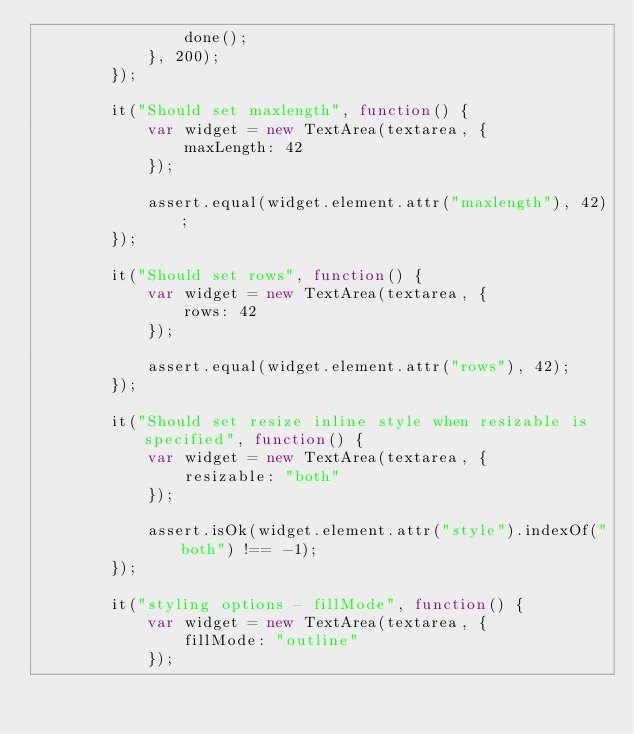Convert code to text. <code><loc_0><loc_0><loc_500><loc_500><_JavaScript_>                done();
            }, 200);
        });

        it("Should set maxlength", function() {
            var widget = new TextArea(textarea, {
                maxLength: 42
            });

            assert.equal(widget.element.attr("maxlength"), 42);
        });

        it("Should set rows", function() {
            var widget = new TextArea(textarea, {
                rows: 42
            });

            assert.equal(widget.element.attr("rows"), 42);
        });

        it("Should set resize inline style when resizable is specified", function() {
            var widget = new TextArea(textarea, {
                resizable: "both"
            });

            assert.isOk(widget.element.attr("style").indexOf("both") !== -1);
        });

        it("styling options - fillMode", function() {
            var widget = new TextArea(textarea, {
                fillMode: "outline"
            });
</code> 